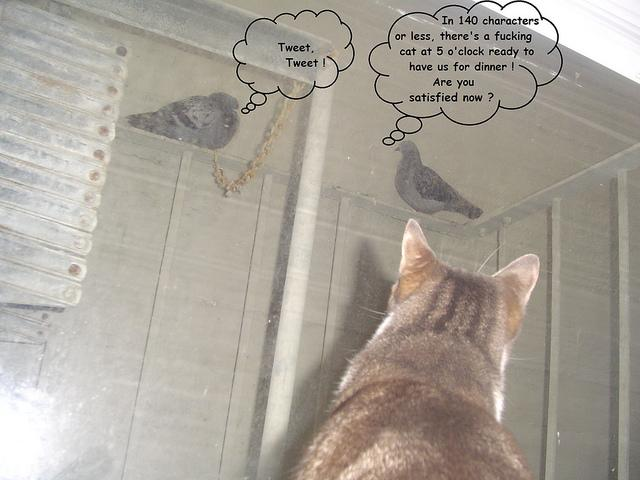The dialogue bubbles are an example of what editing technique?

Choices:
A) hue
B) superimposition
C) opacity
D) masking superimposition 